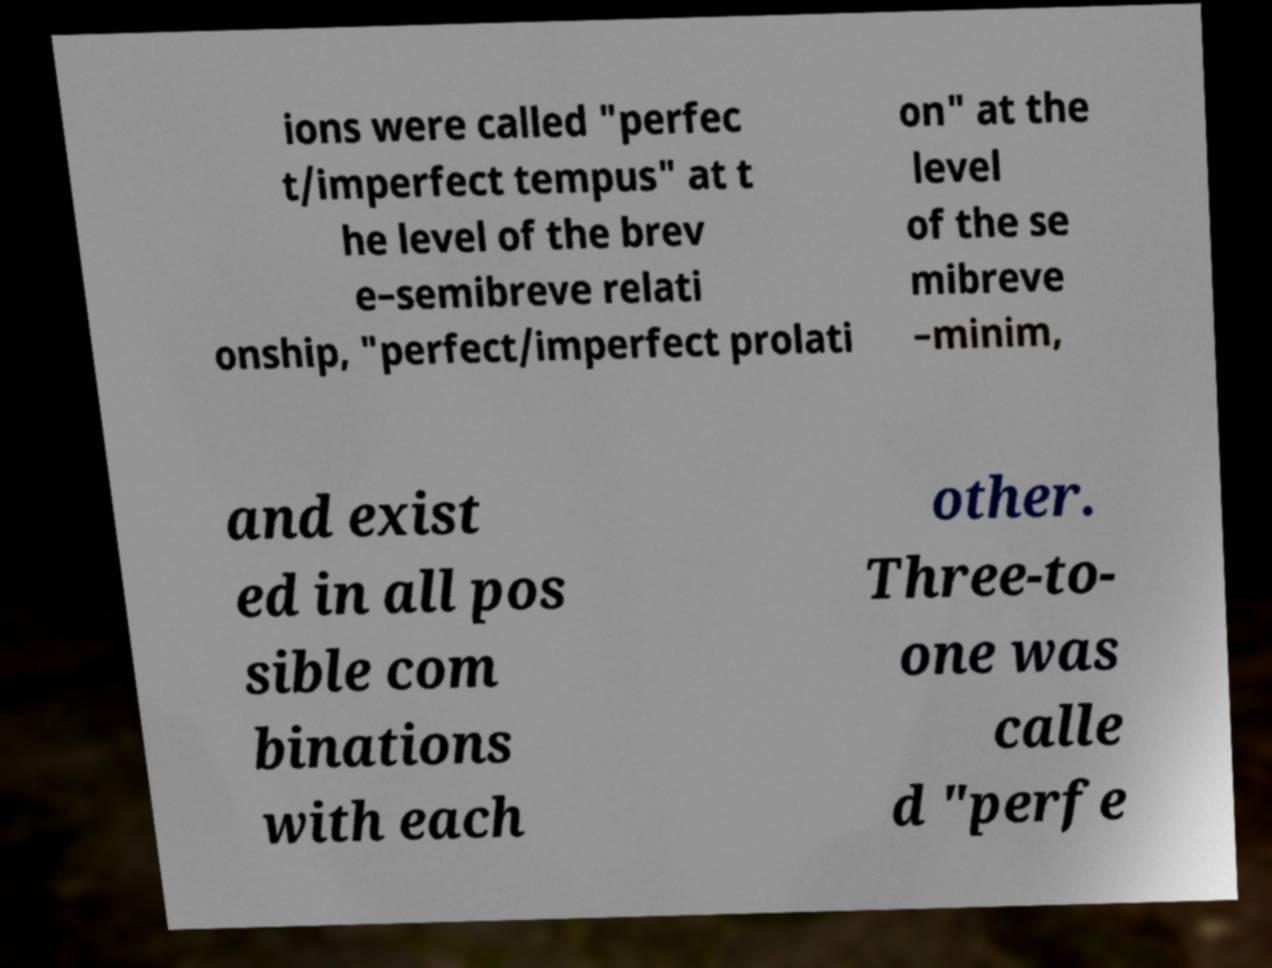Could you extract and type out the text from this image? ions were called "perfec t/imperfect tempus" at t he level of the brev e–semibreve relati onship, "perfect/imperfect prolati on" at the level of the se mibreve –minim, and exist ed in all pos sible com binations with each other. Three-to- one was calle d "perfe 